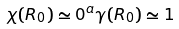Convert formula to latex. <formula><loc_0><loc_0><loc_500><loc_500>\chi ( R _ { 0 } ) \simeq 0 ^ { a } \gamma ( R _ { 0 } ) \simeq 1</formula> 